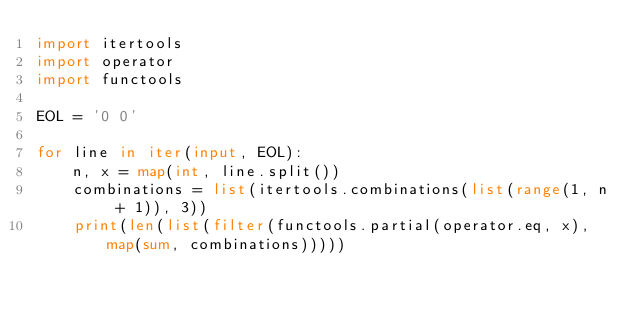<code> <loc_0><loc_0><loc_500><loc_500><_Python_>import itertools
import operator
import functools

EOL = '0 0'

for line in iter(input, EOL):
    n, x = map(int, line.split())
    combinations = list(itertools.combinations(list(range(1, n + 1)), 3))
    print(len(list(filter(functools.partial(operator.eq, x), map(sum, combinations)))))

</code> 